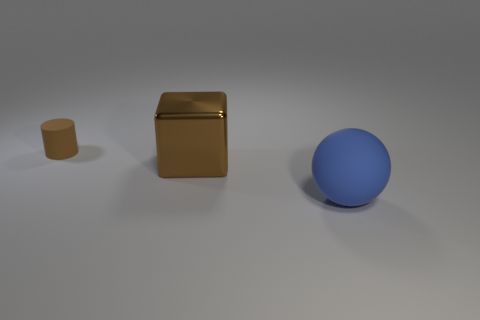Add 1 metal cylinders. How many objects exist? 4 Subtract 1 spheres. How many spheres are left? 0 Subtract all cyan cylinders. Subtract all green balls. How many cylinders are left? 1 Subtract all brown spheres. How many red blocks are left? 0 Subtract all purple rubber things. Subtract all tiny brown things. How many objects are left? 2 Add 3 large metal things. How many large metal things are left? 4 Add 1 brown metal blocks. How many brown metal blocks exist? 2 Subtract 1 blue balls. How many objects are left? 2 Subtract all spheres. How many objects are left? 2 